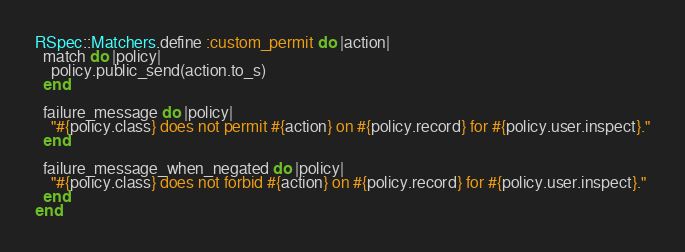<code> <loc_0><loc_0><loc_500><loc_500><_Ruby_>
RSpec::Matchers.define :custom_permit do |action|
  match do |policy|
    policy.public_send(action.to_s)
  end

  failure_message do |policy|
    "#{policy.class} does not permit #{action} on #{policy.record} for #{policy.user.inspect}."
  end

  failure_message_when_negated do |policy|
    "#{policy.class} does not forbid #{action} on #{policy.record} for #{policy.user.inspect}."
  end
end
</code> 